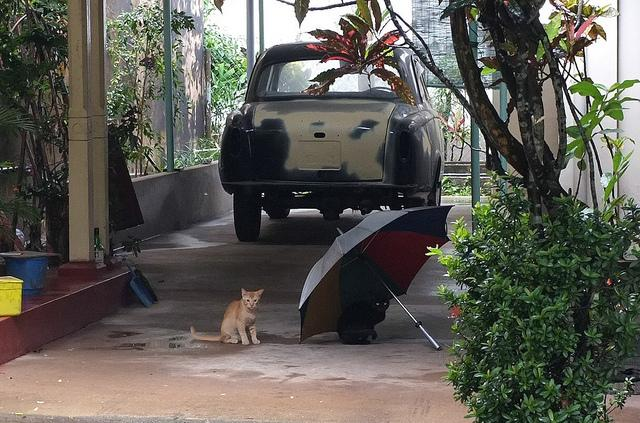What is under the umbrella? Please explain your reasoning. black cat. There are felines, not people. the one under the umbrella has dark fur. 